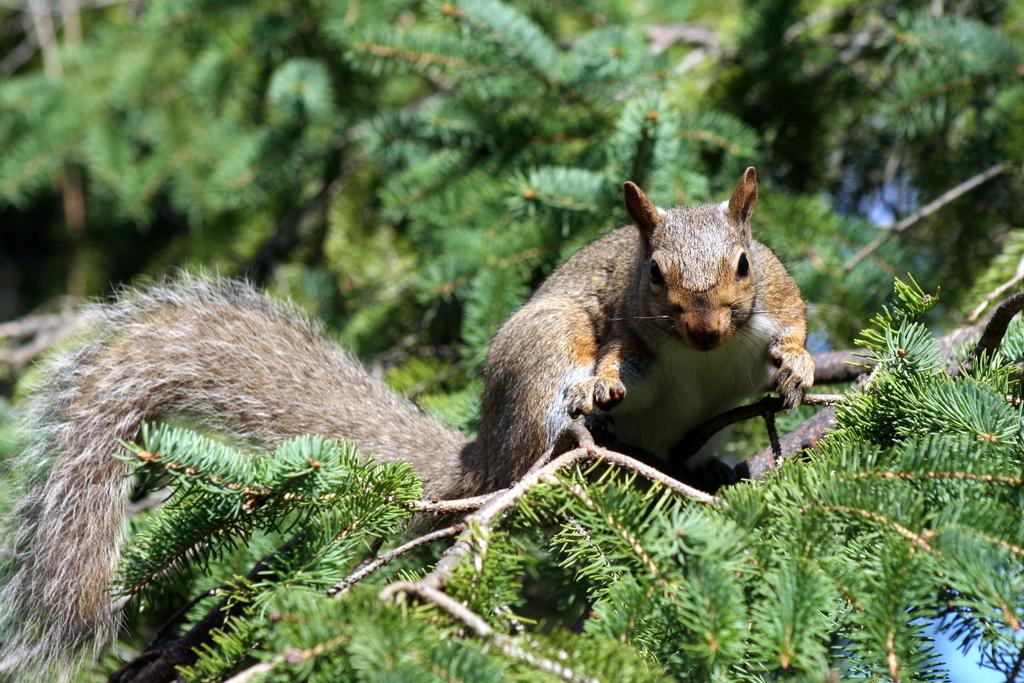What animal can be seen in the image? There is a squirrel in the image. Where is the squirrel located? The squirrel is on the branch of a tree. What type of nerve can be seen in the image? There are no nerves present in the image; it features a squirrel on a tree branch. What question is the squirrel asking in the image? Squirrels do not ask questions, as they are animals and do not have the ability to communicate through language. 